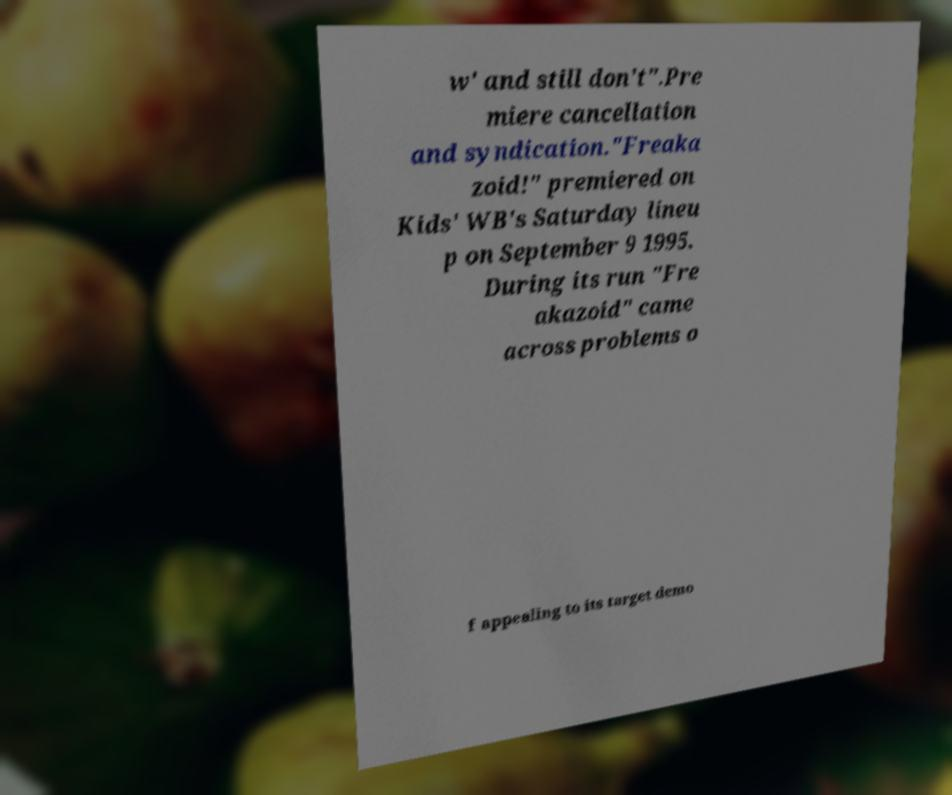There's text embedded in this image that I need extracted. Can you transcribe it verbatim? w' and still don't".Pre miere cancellation and syndication."Freaka zoid!" premiered on Kids' WB's Saturday lineu p on September 9 1995. During its run "Fre akazoid" came across problems o f appealing to its target demo 